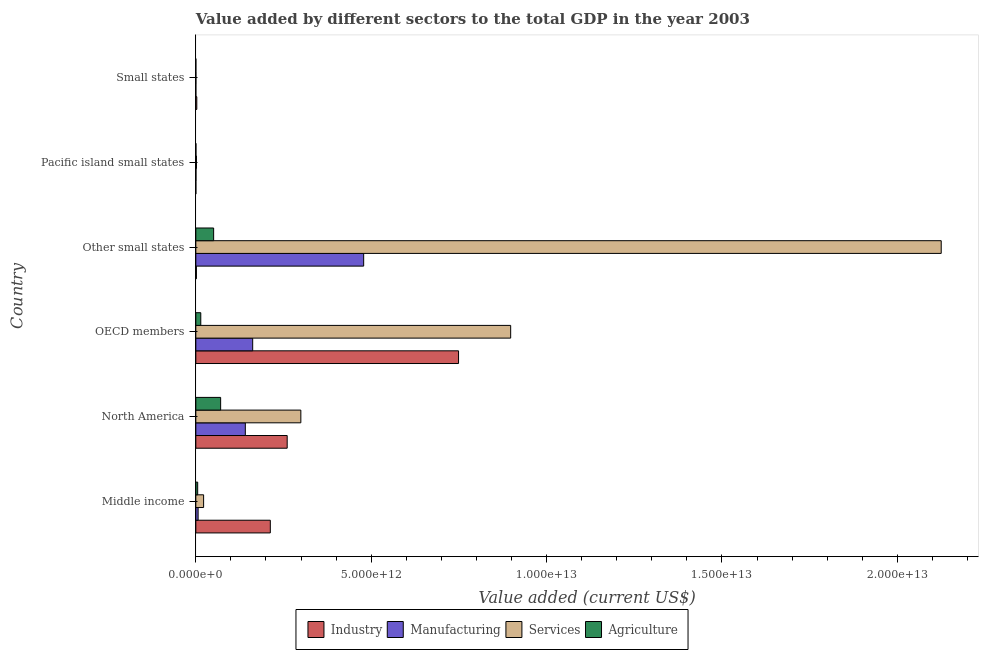How many groups of bars are there?
Provide a short and direct response. 6. Are the number of bars on each tick of the Y-axis equal?
Your answer should be very brief. Yes. How many bars are there on the 6th tick from the top?
Provide a succinct answer. 4. How many bars are there on the 1st tick from the bottom?
Provide a short and direct response. 4. What is the label of the 3rd group of bars from the top?
Keep it short and to the point. Other small states. In how many cases, is the number of bars for a given country not equal to the number of legend labels?
Offer a very short reply. 0. What is the value added by agricultural sector in Middle income?
Keep it short and to the point. 5.31e+1. Across all countries, what is the maximum value added by agricultural sector?
Offer a very short reply. 7.08e+11. Across all countries, what is the minimum value added by manufacturing sector?
Provide a succinct answer. 4.16e+08. In which country was the value added by services sector maximum?
Provide a succinct answer. Other small states. In which country was the value added by services sector minimum?
Make the answer very short. Small states. What is the total value added by manufacturing sector in the graph?
Keep it short and to the point. 7.89e+12. What is the difference between the value added by manufacturing sector in Middle income and that in Small states?
Offer a terse response. 6.48e+1. What is the difference between the value added by agricultural sector in Small states and the value added by services sector in Other small states?
Offer a very short reply. -2.13e+13. What is the average value added by industrial sector per country?
Ensure brevity in your answer.  2.04e+12. What is the difference between the value added by agricultural sector and value added by industrial sector in OECD members?
Give a very brief answer. -7.35e+12. In how many countries, is the value added by industrial sector greater than 4000000000000 US$?
Ensure brevity in your answer.  1. What is the ratio of the value added by agricultural sector in OECD members to that in Other small states?
Offer a very short reply. 0.28. Is the value added by agricultural sector in Other small states less than that in Pacific island small states?
Your answer should be compact. No. What is the difference between the highest and the second highest value added by industrial sector?
Keep it short and to the point. 4.89e+12. What is the difference between the highest and the lowest value added by manufacturing sector?
Your response must be concise. 4.78e+12. In how many countries, is the value added by agricultural sector greater than the average value added by agricultural sector taken over all countries?
Your answer should be compact. 2. What does the 2nd bar from the top in Pacific island small states represents?
Offer a terse response. Services. What does the 3rd bar from the bottom in OECD members represents?
Give a very brief answer. Services. Is it the case that in every country, the sum of the value added by industrial sector and value added by manufacturing sector is greater than the value added by services sector?
Offer a very short reply. No. Are all the bars in the graph horizontal?
Provide a succinct answer. Yes. How many countries are there in the graph?
Your answer should be compact. 6. What is the difference between two consecutive major ticks on the X-axis?
Your answer should be compact. 5.00e+12. Does the graph contain any zero values?
Offer a terse response. No. Does the graph contain grids?
Keep it short and to the point. No. Where does the legend appear in the graph?
Give a very brief answer. Bottom center. What is the title of the graph?
Keep it short and to the point. Value added by different sectors to the total GDP in the year 2003. What is the label or title of the X-axis?
Provide a short and direct response. Value added (current US$). What is the label or title of the Y-axis?
Keep it short and to the point. Country. What is the Value added (current US$) in Industry in Middle income?
Keep it short and to the point. 2.12e+12. What is the Value added (current US$) in Manufacturing in Middle income?
Your answer should be compact. 6.52e+1. What is the Value added (current US$) in Services in Middle income?
Offer a terse response. 2.22e+11. What is the Value added (current US$) in Agriculture in Middle income?
Your answer should be very brief. 5.31e+1. What is the Value added (current US$) of Industry in North America?
Your answer should be very brief. 2.60e+12. What is the Value added (current US$) in Manufacturing in North America?
Give a very brief answer. 1.41e+12. What is the Value added (current US$) in Services in North America?
Keep it short and to the point. 2.99e+12. What is the Value added (current US$) of Agriculture in North America?
Offer a terse response. 7.08e+11. What is the Value added (current US$) of Industry in OECD members?
Your answer should be very brief. 7.49e+12. What is the Value added (current US$) of Manufacturing in OECD members?
Give a very brief answer. 1.62e+12. What is the Value added (current US$) in Services in OECD members?
Make the answer very short. 8.98e+12. What is the Value added (current US$) in Agriculture in OECD members?
Offer a very short reply. 1.41e+11. What is the Value added (current US$) of Industry in Other small states?
Provide a succinct answer. 1.64e+1. What is the Value added (current US$) of Manufacturing in Other small states?
Keep it short and to the point. 4.79e+12. What is the Value added (current US$) of Services in Other small states?
Make the answer very short. 2.13e+13. What is the Value added (current US$) of Agriculture in Other small states?
Offer a terse response. 5.08e+11. What is the Value added (current US$) of Industry in Pacific island small states?
Offer a very short reply. 7.09e+08. What is the Value added (current US$) of Manufacturing in Pacific island small states?
Give a very brief answer. 4.13e+09. What is the Value added (current US$) in Services in Pacific island small states?
Offer a very short reply. 1.76e+1. What is the Value added (current US$) of Agriculture in Pacific island small states?
Ensure brevity in your answer.  2.92e+09. What is the Value added (current US$) of Industry in Small states?
Ensure brevity in your answer.  2.75e+1. What is the Value added (current US$) of Manufacturing in Small states?
Offer a terse response. 4.16e+08. What is the Value added (current US$) of Services in Small states?
Provide a short and direct response. 2.27e+09. What is the Value added (current US$) in Agriculture in Small states?
Ensure brevity in your answer.  6.69e+08. Across all countries, what is the maximum Value added (current US$) of Industry?
Give a very brief answer. 7.49e+12. Across all countries, what is the maximum Value added (current US$) of Manufacturing?
Offer a very short reply. 4.79e+12. Across all countries, what is the maximum Value added (current US$) in Services?
Your answer should be compact. 2.13e+13. Across all countries, what is the maximum Value added (current US$) in Agriculture?
Your answer should be compact. 7.08e+11. Across all countries, what is the minimum Value added (current US$) in Industry?
Keep it short and to the point. 7.09e+08. Across all countries, what is the minimum Value added (current US$) in Manufacturing?
Offer a very short reply. 4.16e+08. Across all countries, what is the minimum Value added (current US$) in Services?
Provide a short and direct response. 2.27e+09. Across all countries, what is the minimum Value added (current US$) of Agriculture?
Give a very brief answer. 6.69e+08. What is the total Value added (current US$) of Industry in the graph?
Provide a short and direct response. 1.23e+13. What is the total Value added (current US$) in Manufacturing in the graph?
Ensure brevity in your answer.  7.89e+12. What is the total Value added (current US$) in Services in the graph?
Your answer should be compact. 3.35e+13. What is the total Value added (current US$) in Agriculture in the graph?
Provide a short and direct response. 1.41e+12. What is the difference between the Value added (current US$) of Industry in Middle income and that in North America?
Give a very brief answer. -4.81e+11. What is the difference between the Value added (current US$) in Manufacturing in Middle income and that in North America?
Keep it short and to the point. -1.35e+12. What is the difference between the Value added (current US$) of Services in Middle income and that in North America?
Your answer should be very brief. -2.77e+12. What is the difference between the Value added (current US$) of Agriculture in Middle income and that in North America?
Provide a succinct answer. -6.54e+11. What is the difference between the Value added (current US$) in Industry in Middle income and that in OECD members?
Offer a very short reply. -5.37e+12. What is the difference between the Value added (current US$) in Manufacturing in Middle income and that in OECD members?
Provide a short and direct response. -1.56e+12. What is the difference between the Value added (current US$) in Services in Middle income and that in OECD members?
Keep it short and to the point. -8.75e+12. What is the difference between the Value added (current US$) in Agriculture in Middle income and that in OECD members?
Offer a very short reply. -8.81e+1. What is the difference between the Value added (current US$) of Industry in Middle income and that in Other small states?
Ensure brevity in your answer.  2.11e+12. What is the difference between the Value added (current US$) of Manufacturing in Middle income and that in Other small states?
Offer a very short reply. -4.72e+12. What is the difference between the Value added (current US$) of Services in Middle income and that in Other small states?
Keep it short and to the point. -2.10e+13. What is the difference between the Value added (current US$) in Agriculture in Middle income and that in Other small states?
Make the answer very short. -4.55e+11. What is the difference between the Value added (current US$) of Industry in Middle income and that in Pacific island small states?
Offer a very short reply. 2.12e+12. What is the difference between the Value added (current US$) of Manufacturing in Middle income and that in Pacific island small states?
Your answer should be very brief. 6.11e+1. What is the difference between the Value added (current US$) of Services in Middle income and that in Pacific island small states?
Keep it short and to the point. 2.04e+11. What is the difference between the Value added (current US$) of Agriculture in Middle income and that in Pacific island small states?
Your answer should be very brief. 5.02e+1. What is the difference between the Value added (current US$) in Industry in Middle income and that in Small states?
Your response must be concise. 2.10e+12. What is the difference between the Value added (current US$) in Manufacturing in Middle income and that in Small states?
Provide a short and direct response. 6.48e+1. What is the difference between the Value added (current US$) in Services in Middle income and that in Small states?
Offer a terse response. 2.20e+11. What is the difference between the Value added (current US$) in Agriculture in Middle income and that in Small states?
Ensure brevity in your answer.  5.24e+1. What is the difference between the Value added (current US$) in Industry in North America and that in OECD members?
Offer a terse response. -4.89e+12. What is the difference between the Value added (current US$) in Manufacturing in North America and that in OECD members?
Keep it short and to the point. -2.10e+11. What is the difference between the Value added (current US$) in Services in North America and that in OECD members?
Provide a succinct answer. -5.98e+12. What is the difference between the Value added (current US$) in Agriculture in North America and that in OECD members?
Ensure brevity in your answer.  5.66e+11. What is the difference between the Value added (current US$) in Industry in North America and that in Other small states?
Your answer should be very brief. 2.59e+12. What is the difference between the Value added (current US$) of Manufacturing in North America and that in Other small states?
Make the answer very short. -3.37e+12. What is the difference between the Value added (current US$) in Services in North America and that in Other small states?
Make the answer very short. -1.83e+13. What is the difference between the Value added (current US$) of Agriculture in North America and that in Other small states?
Give a very brief answer. 2.00e+11. What is the difference between the Value added (current US$) of Industry in North America and that in Pacific island small states?
Keep it short and to the point. 2.60e+12. What is the difference between the Value added (current US$) in Manufacturing in North America and that in Pacific island small states?
Your answer should be very brief. 1.41e+12. What is the difference between the Value added (current US$) of Services in North America and that in Pacific island small states?
Your answer should be very brief. 2.98e+12. What is the difference between the Value added (current US$) of Agriculture in North America and that in Pacific island small states?
Keep it short and to the point. 7.05e+11. What is the difference between the Value added (current US$) in Industry in North America and that in Small states?
Provide a succinct answer. 2.58e+12. What is the difference between the Value added (current US$) of Manufacturing in North America and that in Small states?
Keep it short and to the point. 1.41e+12. What is the difference between the Value added (current US$) in Services in North America and that in Small states?
Provide a short and direct response. 2.99e+12. What is the difference between the Value added (current US$) in Agriculture in North America and that in Small states?
Keep it short and to the point. 7.07e+11. What is the difference between the Value added (current US$) in Industry in OECD members and that in Other small states?
Your answer should be very brief. 7.47e+12. What is the difference between the Value added (current US$) of Manufacturing in OECD members and that in Other small states?
Give a very brief answer. -3.16e+12. What is the difference between the Value added (current US$) in Services in OECD members and that in Other small states?
Give a very brief answer. -1.23e+13. What is the difference between the Value added (current US$) of Agriculture in OECD members and that in Other small states?
Offer a terse response. -3.67e+11. What is the difference between the Value added (current US$) in Industry in OECD members and that in Pacific island small states?
Provide a succinct answer. 7.49e+12. What is the difference between the Value added (current US$) in Manufacturing in OECD members and that in Pacific island small states?
Keep it short and to the point. 1.62e+12. What is the difference between the Value added (current US$) in Services in OECD members and that in Pacific island small states?
Provide a short and direct response. 8.96e+12. What is the difference between the Value added (current US$) of Agriculture in OECD members and that in Pacific island small states?
Your response must be concise. 1.38e+11. What is the difference between the Value added (current US$) in Industry in OECD members and that in Small states?
Offer a very short reply. 7.46e+12. What is the difference between the Value added (current US$) in Manufacturing in OECD members and that in Small states?
Give a very brief answer. 1.62e+12. What is the difference between the Value added (current US$) of Services in OECD members and that in Small states?
Ensure brevity in your answer.  8.97e+12. What is the difference between the Value added (current US$) in Agriculture in OECD members and that in Small states?
Offer a very short reply. 1.41e+11. What is the difference between the Value added (current US$) of Industry in Other small states and that in Pacific island small states?
Provide a short and direct response. 1.57e+1. What is the difference between the Value added (current US$) of Manufacturing in Other small states and that in Pacific island small states?
Your answer should be compact. 4.78e+12. What is the difference between the Value added (current US$) of Services in Other small states and that in Pacific island small states?
Keep it short and to the point. 2.12e+13. What is the difference between the Value added (current US$) in Agriculture in Other small states and that in Pacific island small states?
Offer a terse response. 5.05e+11. What is the difference between the Value added (current US$) of Industry in Other small states and that in Small states?
Make the answer very short. -1.11e+1. What is the difference between the Value added (current US$) in Manufacturing in Other small states and that in Small states?
Your answer should be compact. 4.78e+12. What is the difference between the Value added (current US$) in Services in Other small states and that in Small states?
Your answer should be compact. 2.12e+13. What is the difference between the Value added (current US$) in Agriculture in Other small states and that in Small states?
Your response must be concise. 5.07e+11. What is the difference between the Value added (current US$) of Industry in Pacific island small states and that in Small states?
Ensure brevity in your answer.  -2.68e+1. What is the difference between the Value added (current US$) in Manufacturing in Pacific island small states and that in Small states?
Your answer should be very brief. 3.71e+09. What is the difference between the Value added (current US$) of Services in Pacific island small states and that in Small states?
Offer a terse response. 1.54e+1. What is the difference between the Value added (current US$) in Agriculture in Pacific island small states and that in Small states?
Your response must be concise. 2.25e+09. What is the difference between the Value added (current US$) in Industry in Middle income and the Value added (current US$) in Manufacturing in North America?
Your answer should be very brief. 7.12e+11. What is the difference between the Value added (current US$) of Industry in Middle income and the Value added (current US$) of Services in North America?
Your answer should be compact. -8.70e+11. What is the difference between the Value added (current US$) in Industry in Middle income and the Value added (current US$) in Agriculture in North America?
Your answer should be compact. 1.42e+12. What is the difference between the Value added (current US$) in Manufacturing in Middle income and the Value added (current US$) in Services in North America?
Ensure brevity in your answer.  -2.93e+12. What is the difference between the Value added (current US$) in Manufacturing in Middle income and the Value added (current US$) in Agriculture in North America?
Provide a short and direct response. -6.42e+11. What is the difference between the Value added (current US$) in Services in Middle income and the Value added (current US$) in Agriculture in North America?
Ensure brevity in your answer.  -4.86e+11. What is the difference between the Value added (current US$) in Industry in Middle income and the Value added (current US$) in Manufacturing in OECD members?
Make the answer very short. 5.03e+11. What is the difference between the Value added (current US$) in Industry in Middle income and the Value added (current US$) in Services in OECD members?
Your response must be concise. -6.85e+12. What is the difference between the Value added (current US$) in Industry in Middle income and the Value added (current US$) in Agriculture in OECD members?
Offer a very short reply. 1.98e+12. What is the difference between the Value added (current US$) in Manufacturing in Middle income and the Value added (current US$) in Services in OECD members?
Keep it short and to the point. -8.91e+12. What is the difference between the Value added (current US$) of Manufacturing in Middle income and the Value added (current US$) of Agriculture in OECD members?
Offer a terse response. -7.60e+1. What is the difference between the Value added (current US$) of Services in Middle income and the Value added (current US$) of Agriculture in OECD members?
Ensure brevity in your answer.  8.07e+1. What is the difference between the Value added (current US$) of Industry in Middle income and the Value added (current US$) of Manufacturing in Other small states?
Your response must be concise. -2.66e+12. What is the difference between the Value added (current US$) of Industry in Middle income and the Value added (current US$) of Services in Other small states?
Your answer should be very brief. -1.91e+13. What is the difference between the Value added (current US$) of Industry in Middle income and the Value added (current US$) of Agriculture in Other small states?
Make the answer very short. 1.62e+12. What is the difference between the Value added (current US$) in Manufacturing in Middle income and the Value added (current US$) in Services in Other small states?
Your answer should be very brief. -2.12e+13. What is the difference between the Value added (current US$) of Manufacturing in Middle income and the Value added (current US$) of Agriculture in Other small states?
Your answer should be compact. -4.43e+11. What is the difference between the Value added (current US$) of Services in Middle income and the Value added (current US$) of Agriculture in Other small states?
Offer a very short reply. -2.86e+11. What is the difference between the Value added (current US$) of Industry in Middle income and the Value added (current US$) of Manufacturing in Pacific island small states?
Ensure brevity in your answer.  2.12e+12. What is the difference between the Value added (current US$) in Industry in Middle income and the Value added (current US$) in Services in Pacific island small states?
Offer a terse response. 2.11e+12. What is the difference between the Value added (current US$) in Industry in Middle income and the Value added (current US$) in Agriculture in Pacific island small states?
Offer a terse response. 2.12e+12. What is the difference between the Value added (current US$) in Manufacturing in Middle income and the Value added (current US$) in Services in Pacific island small states?
Your answer should be compact. 4.76e+1. What is the difference between the Value added (current US$) of Manufacturing in Middle income and the Value added (current US$) of Agriculture in Pacific island small states?
Keep it short and to the point. 6.23e+1. What is the difference between the Value added (current US$) of Services in Middle income and the Value added (current US$) of Agriculture in Pacific island small states?
Provide a succinct answer. 2.19e+11. What is the difference between the Value added (current US$) in Industry in Middle income and the Value added (current US$) in Manufacturing in Small states?
Your answer should be compact. 2.12e+12. What is the difference between the Value added (current US$) in Industry in Middle income and the Value added (current US$) in Services in Small states?
Your answer should be compact. 2.12e+12. What is the difference between the Value added (current US$) in Industry in Middle income and the Value added (current US$) in Agriculture in Small states?
Ensure brevity in your answer.  2.12e+12. What is the difference between the Value added (current US$) in Manufacturing in Middle income and the Value added (current US$) in Services in Small states?
Your answer should be very brief. 6.29e+1. What is the difference between the Value added (current US$) of Manufacturing in Middle income and the Value added (current US$) of Agriculture in Small states?
Provide a succinct answer. 6.45e+1. What is the difference between the Value added (current US$) of Services in Middle income and the Value added (current US$) of Agriculture in Small states?
Your answer should be very brief. 2.21e+11. What is the difference between the Value added (current US$) in Industry in North America and the Value added (current US$) in Manufacturing in OECD members?
Your response must be concise. 9.84e+11. What is the difference between the Value added (current US$) of Industry in North America and the Value added (current US$) of Services in OECD members?
Make the answer very short. -6.37e+12. What is the difference between the Value added (current US$) of Industry in North America and the Value added (current US$) of Agriculture in OECD members?
Keep it short and to the point. 2.46e+12. What is the difference between the Value added (current US$) of Manufacturing in North America and the Value added (current US$) of Services in OECD members?
Your answer should be very brief. -7.57e+12. What is the difference between the Value added (current US$) in Manufacturing in North America and the Value added (current US$) in Agriculture in OECD members?
Offer a very short reply. 1.27e+12. What is the difference between the Value added (current US$) in Services in North America and the Value added (current US$) in Agriculture in OECD members?
Give a very brief answer. 2.85e+12. What is the difference between the Value added (current US$) in Industry in North America and the Value added (current US$) in Manufacturing in Other small states?
Keep it short and to the point. -2.18e+12. What is the difference between the Value added (current US$) of Industry in North America and the Value added (current US$) of Services in Other small states?
Your response must be concise. -1.86e+13. What is the difference between the Value added (current US$) in Industry in North America and the Value added (current US$) in Agriculture in Other small states?
Your answer should be very brief. 2.10e+12. What is the difference between the Value added (current US$) in Manufacturing in North America and the Value added (current US$) in Services in Other small states?
Make the answer very short. -1.98e+13. What is the difference between the Value added (current US$) in Manufacturing in North America and the Value added (current US$) in Agriculture in Other small states?
Your answer should be compact. 9.03e+11. What is the difference between the Value added (current US$) of Services in North America and the Value added (current US$) of Agriculture in Other small states?
Your response must be concise. 2.49e+12. What is the difference between the Value added (current US$) in Industry in North America and the Value added (current US$) in Manufacturing in Pacific island small states?
Offer a terse response. 2.60e+12. What is the difference between the Value added (current US$) of Industry in North America and the Value added (current US$) of Services in Pacific island small states?
Give a very brief answer. 2.59e+12. What is the difference between the Value added (current US$) of Industry in North America and the Value added (current US$) of Agriculture in Pacific island small states?
Make the answer very short. 2.60e+12. What is the difference between the Value added (current US$) of Manufacturing in North America and the Value added (current US$) of Services in Pacific island small states?
Provide a short and direct response. 1.39e+12. What is the difference between the Value added (current US$) of Manufacturing in North America and the Value added (current US$) of Agriculture in Pacific island small states?
Your answer should be compact. 1.41e+12. What is the difference between the Value added (current US$) of Services in North America and the Value added (current US$) of Agriculture in Pacific island small states?
Your answer should be very brief. 2.99e+12. What is the difference between the Value added (current US$) in Industry in North America and the Value added (current US$) in Manufacturing in Small states?
Make the answer very short. 2.60e+12. What is the difference between the Value added (current US$) in Industry in North America and the Value added (current US$) in Services in Small states?
Give a very brief answer. 2.60e+12. What is the difference between the Value added (current US$) in Industry in North America and the Value added (current US$) in Agriculture in Small states?
Offer a very short reply. 2.60e+12. What is the difference between the Value added (current US$) of Manufacturing in North America and the Value added (current US$) of Services in Small states?
Provide a short and direct response. 1.41e+12. What is the difference between the Value added (current US$) of Manufacturing in North America and the Value added (current US$) of Agriculture in Small states?
Your answer should be compact. 1.41e+12. What is the difference between the Value added (current US$) in Services in North America and the Value added (current US$) in Agriculture in Small states?
Your response must be concise. 2.99e+12. What is the difference between the Value added (current US$) in Industry in OECD members and the Value added (current US$) in Manufacturing in Other small states?
Ensure brevity in your answer.  2.71e+12. What is the difference between the Value added (current US$) of Industry in OECD members and the Value added (current US$) of Services in Other small states?
Provide a succinct answer. -1.38e+13. What is the difference between the Value added (current US$) in Industry in OECD members and the Value added (current US$) in Agriculture in Other small states?
Provide a short and direct response. 6.98e+12. What is the difference between the Value added (current US$) of Manufacturing in OECD members and the Value added (current US$) of Services in Other small states?
Your answer should be compact. -1.96e+13. What is the difference between the Value added (current US$) of Manufacturing in OECD members and the Value added (current US$) of Agriculture in Other small states?
Ensure brevity in your answer.  1.11e+12. What is the difference between the Value added (current US$) of Services in OECD members and the Value added (current US$) of Agriculture in Other small states?
Give a very brief answer. 8.47e+12. What is the difference between the Value added (current US$) of Industry in OECD members and the Value added (current US$) of Manufacturing in Pacific island small states?
Ensure brevity in your answer.  7.49e+12. What is the difference between the Value added (current US$) of Industry in OECD members and the Value added (current US$) of Services in Pacific island small states?
Provide a succinct answer. 7.47e+12. What is the difference between the Value added (current US$) in Industry in OECD members and the Value added (current US$) in Agriculture in Pacific island small states?
Make the answer very short. 7.49e+12. What is the difference between the Value added (current US$) of Manufacturing in OECD members and the Value added (current US$) of Services in Pacific island small states?
Give a very brief answer. 1.60e+12. What is the difference between the Value added (current US$) of Manufacturing in OECD members and the Value added (current US$) of Agriculture in Pacific island small states?
Offer a terse response. 1.62e+12. What is the difference between the Value added (current US$) in Services in OECD members and the Value added (current US$) in Agriculture in Pacific island small states?
Your answer should be compact. 8.97e+12. What is the difference between the Value added (current US$) of Industry in OECD members and the Value added (current US$) of Manufacturing in Small states?
Offer a terse response. 7.49e+12. What is the difference between the Value added (current US$) in Industry in OECD members and the Value added (current US$) in Services in Small states?
Give a very brief answer. 7.49e+12. What is the difference between the Value added (current US$) of Industry in OECD members and the Value added (current US$) of Agriculture in Small states?
Your answer should be compact. 7.49e+12. What is the difference between the Value added (current US$) of Manufacturing in OECD members and the Value added (current US$) of Services in Small states?
Your answer should be compact. 1.62e+12. What is the difference between the Value added (current US$) of Manufacturing in OECD members and the Value added (current US$) of Agriculture in Small states?
Your answer should be compact. 1.62e+12. What is the difference between the Value added (current US$) in Services in OECD members and the Value added (current US$) in Agriculture in Small states?
Provide a short and direct response. 8.98e+12. What is the difference between the Value added (current US$) of Industry in Other small states and the Value added (current US$) of Manufacturing in Pacific island small states?
Your answer should be very brief. 1.23e+1. What is the difference between the Value added (current US$) of Industry in Other small states and the Value added (current US$) of Services in Pacific island small states?
Offer a terse response. -1.22e+09. What is the difference between the Value added (current US$) of Industry in Other small states and the Value added (current US$) of Agriculture in Pacific island small states?
Make the answer very short. 1.35e+1. What is the difference between the Value added (current US$) of Manufacturing in Other small states and the Value added (current US$) of Services in Pacific island small states?
Provide a short and direct response. 4.77e+12. What is the difference between the Value added (current US$) of Manufacturing in Other small states and the Value added (current US$) of Agriculture in Pacific island small states?
Make the answer very short. 4.78e+12. What is the difference between the Value added (current US$) in Services in Other small states and the Value added (current US$) in Agriculture in Pacific island small states?
Provide a short and direct response. 2.12e+13. What is the difference between the Value added (current US$) of Industry in Other small states and the Value added (current US$) of Manufacturing in Small states?
Provide a short and direct response. 1.60e+1. What is the difference between the Value added (current US$) of Industry in Other small states and the Value added (current US$) of Services in Small states?
Your response must be concise. 1.41e+1. What is the difference between the Value added (current US$) in Industry in Other small states and the Value added (current US$) in Agriculture in Small states?
Provide a short and direct response. 1.57e+1. What is the difference between the Value added (current US$) of Manufacturing in Other small states and the Value added (current US$) of Services in Small states?
Keep it short and to the point. 4.78e+12. What is the difference between the Value added (current US$) of Manufacturing in Other small states and the Value added (current US$) of Agriculture in Small states?
Your answer should be compact. 4.78e+12. What is the difference between the Value added (current US$) in Services in Other small states and the Value added (current US$) in Agriculture in Small states?
Give a very brief answer. 2.13e+13. What is the difference between the Value added (current US$) in Industry in Pacific island small states and the Value added (current US$) in Manufacturing in Small states?
Offer a very short reply. 2.93e+08. What is the difference between the Value added (current US$) in Industry in Pacific island small states and the Value added (current US$) in Services in Small states?
Your response must be concise. -1.56e+09. What is the difference between the Value added (current US$) in Industry in Pacific island small states and the Value added (current US$) in Agriculture in Small states?
Offer a very short reply. 4.02e+07. What is the difference between the Value added (current US$) in Manufacturing in Pacific island small states and the Value added (current US$) in Services in Small states?
Ensure brevity in your answer.  1.86e+09. What is the difference between the Value added (current US$) in Manufacturing in Pacific island small states and the Value added (current US$) in Agriculture in Small states?
Your answer should be very brief. 3.46e+09. What is the difference between the Value added (current US$) of Services in Pacific island small states and the Value added (current US$) of Agriculture in Small states?
Your answer should be very brief. 1.70e+1. What is the average Value added (current US$) of Industry per country?
Provide a succinct answer. 2.04e+12. What is the average Value added (current US$) of Manufacturing per country?
Your response must be concise. 1.31e+12. What is the average Value added (current US$) in Services per country?
Your answer should be compact. 5.58e+12. What is the average Value added (current US$) of Agriculture per country?
Offer a very short reply. 2.36e+11. What is the difference between the Value added (current US$) in Industry and Value added (current US$) in Manufacturing in Middle income?
Your response must be concise. 2.06e+12. What is the difference between the Value added (current US$) of Industry and Value added (current US$) of Services in Middle income?
Provide a succinct answer. 1.90e+12. What is the difference between the Value added (current US$) in Industry and Value added (current US$) in Agriculture in Middle income?
Provide a succinct answer. 2.07e+12. What is the difference between the Value added (current US$) of Manufacturing and Value added (current US$) of Services in Middle income?
Your answer should be very brief. -1.57e+11. What is the difference between the Value added (current US$) in Manufacturing and Value added (current US$) in Agriculture in Middle income?
Provide a succinct answer. 1.21e+1. What is the difference between the Value added (current US$) in Services and Value added (current US$) in Agriculture in Middle income?
Your response must be concise. 1.69e+11. What is the difference between the Value added (current US$) of Industry and Value added (current US$) of Manufacturing in North America?
Keep it short and to the point. 1.19e+12. What is the difference between the Value added (current US$) of Industry and Value added (current US$) of Services in North America?
Make the answer very short. -3.89e+11. What is the difference between the Value added (current US$) in Industry and Value added (current US$) in Agriculture in North America?
Provide a short and direct response. 1.90e+12. What is the difference between the Value added (current US$) in Manufacturing and Value added (current US$) in Services in North America?
Your answer should be compact. -1.58e+12. What is the difference between the Value added (current US$) of Manufacturing and Value added (current US$) of Agriculture in North America?
Offer a terse response. 7.04e+11. What is the difference between the Value added (current US$) in Services and Value added (current US$) in Agriculture in North America?
Ensure brevity in your answer.  2.29e+12. What is the difference between the Value added (current US$) of Industry and Value added (current US$) of Manufacturing in OECD members?
Your answer should be compact. 5.87e+12. What is the difference between the Value added (current US$) in Industry and Value added (current US$) in Services in OECD members?
Your answer should be very brief. -1.49e+12. What is the difference between the Value added (current US$) of Industry and Value added (current US$) of Agriculture in OECD members?
Provide a short and direct response. 7.35e+12. What is the difference between the Value added (current US$) in Manufacturing and Value added (current US$) in Services in OECD members?
Offer a very short reply. -7.36e+12. What is the difference between the Value added (current US$) of Manufacturing and Value added (current US$) of Agriculture in OECD members?
Offer a very short reply. 1.48e+12. What is the difference between the Value added (current US$) in Services and Value added (current US$) in Agriculture in OECD members?
Give a very brief answer. 8.84e+12. What is the difference between the Value added (current US$) in Industry and Value added (current US$) in Manufacturing in Other small states?
Your answer should be compact. -4.77e+12. What is the difference between the Value added (current US$) in Industry and Value added (current US$) in Services in Other small states?
Offer a very short reply. -2.12e+13. What is the difference between the Value added (current US$) of Industry and Value added (current US$) of Agriculture in Other small states?
Ensure brevity in your answer.  -4.91e+11. What is the difference between the Value added (current US$) in Manufacturing and Value added (current US$) in Services in Other small states?
Make the answer very short. -1.65e+13. What is the difference between the Value added (current US$) of Manufacturing and Value added (current US$) of Agriculture in Other small states?
Provide a short and direct response. 4.28e+12. What is the difference between the Value added (current US$) of Services and Value added (current US$) of Agriculture in Other small states?
Provide a short and direct response. 2.07e+13. What is the difference between the Value added (current US$) in Industry and Value added (current US$) in Manufacturing in Pacific island small states?
Keep it short and to the point. -3.42e+09. What is the difference between the Value added (current US$) of Industry and Value added (current US$) of Services in Pacific island small states?
Provide a succinct answer. -1.69e+1. What is the difference between the Value added (current US$) of Industry and Value added (current US$) of Agriculture in Pacific island small states?
Provide a succinct answer. -2.21e+09. What is the difference between the Value added (current US$) of Manufacturing and Value added (current US$) of Services in Pacific island small states?
Offer a terse response. -1.35e+1. What is the difference between the Value added (current US$) in Manufacturing and Value added (current US$) in Agriculture in Pacific island small states?
Give a very brief answer. 1.21e+09. What is the difference between the Value added (current US$) in Services and Value added (current US$) in Agriculture in Pacific island small states?
Your answer should be very brief. 1.47e+1. What is the difference between the Value added (current US$) in Industry and Value added (current US$) in Manufacturing in Small states?
Ensure brevity in your answer.  2.71e+1. What is the difference between the Value added (current US$) in Industry and Value added (current US$) in Services in Small states?
Provide a short and direct response. 2.52e+1. What is the difference between the Value added (current US$) of Industry and Value added (current US$) of Agriculture in Small states?
Make the answer very short. 2.68e+1. What is the difference between the Value added (current US$) in Manufacturing and Value added (current US$) in Services in Small states?
Your response must be concise. -1.85e+09. What is the difference between the Value added (current US$) in Manufacturing and Value added (current US$) in Agriculture in Small states?
Provide a succinct answer. -2.53e+08. What is the difference between the Value added (current US$) of Services and Value added (current US$) of Agriculture in Small states?
Give a very brief answer. 1.60e+09. What is the ratio of the Value added (current US$) of Industry in Middle income to that in North America?
Your response must be concise. 0.82. What is the ratio of the Value added (current US$) in Manufacturing in Middle income to that in North America?
Offer a terse response. 0.05. What is the ratio of the Value added (current US$) of Services in Middle income to that in North America?
Make the answer very short. 0.07. What is the ratio of the Value added (current US$) in Agriculture in Middle income to that in North America?
Keep it short and to the point. 0.07. What is the ratio of the Value added (current US$) of Industry in Middle income to that in OECD members?
Make the answer very short. 0.28. What is the ratio of the Value added (current US$) in Manufacturing in Middle income to that in OECD members?
Your response must be concise. 0.04. What is the ratio of the Value added (current US$) in Services in Middle income to that in OECD members?
Your response must be concise. 0.02. What is the ratio of the Value added (current US$) of Agriculture in Middle income to that in OECD members?
Offer a very short reply. 0.38. What is the ratio of the Value added (current US$) in Industry in Middle income to that in Other small states?
Ensure brevity in your answer.  129.37. What is the ratio of the Value added (current US$) in Manufacturing in Middle income to that in Other small states?
Offer a very short reply. 0.01. What is the ratio of the Value added (current US$) of Services in Middle income to that in Other small states?
Keep it short and to the point. 0.01. What is the ratio of the Value added (current US$) of Agriculture in Middle income to that in Other small states?
Your response must be concise. 0.1. What is the ratio of the Value added (current US$) of Industry in Middle income to that in Pacific island small states?
Your answer should be very brief. 2995.25. What is the ratio of the Value added (current US$) in Manufacturing in Middle income to that in Pacific island small states?
Your answer should be compact. 15.8. What is the ratio of the Value added (current US$) of Services in Middle income to that in Pacific island small states?
Offer a very short reply. 12.58. What is the ratio of the Value added (current US$) in Agriculture in Middle income to that in Pacific island small states?
Your response must be concise. 18.21. What is the ratio of the Value added (current US$) in Industry in Middle income to that in Small states?
Make the answer very short. 77.25. What is the ratio of the Value added (current US$) of Manufacturing in Middle income to that in Small states?
Make the answer very short. 156.9. What is the ratio of the Value added (current US$) of Services in Middle income to that in Small states?
Your answer should be compact. 97.83. What is the ratio of the Value added (current US$) in Agriculture in Middle income to that in Small states?
Give a very brief answer. 79.38. What is the ratio of the Value added (current US$) of Industry in North America to that in OECD members?
Provide a succinct answer. 0.35. What is the ratio of the Value added (current US$) of Manufacturing in North America to that in OECD members?
Your answer should be very brief. 0.87. What is the ratio of the Value added (current US$) in Services in North America to that in OECD members?
Your answer should be very brief. 0.33. What is the ratio of the Value added (current US$) in Agriculture in North America to that in OECD members?
Your answer should be compact. 5.01. What is the ratio of the Value added (current US$) in Industry in North America to that in Other small states?
Your answer should be compact. 158.68. What is the ratio of the Value added (current US$) in Manufacturing in North America to that in Other small states?
Offer a terse response. 0.29. What is the ratio of the Value added (current US$) in Services in North America to that in Other small states?
Offer a terse response. 0.14. What is the ratio of the Value added (current US$) of Agriculture in North America to that in Other small states?
Give a very brief answer. 1.39. What is the ratio of the Value added (current US$) in Industry in North America to that in Pacific island small states?
Provide a short and direct response. 3673.73. What is the ratio of the Value added (current US$) in Manufacturing in North America to that in Pacific island small states?
Your response must be concise. 341.91. What is the ratio of the Value added (current US$) in Services in North America to that in Pacific island small states?
Keep it short and to the point. 169.82. What is the ratio of the Value added (current US$) of Agriculture in North America to that in Pacific island small states?
Provide a short and direct response. 242.7. What is the ratio of the Value added (current US$) of Industry in North America to that in Small states?
Your answer should be compact. 94.74. What is the ratio of the Value added (current US$) of Manufacturing in North America to that in Small states?
Your answer should be very brief. 3395.31. What is the ratio of the Value added (current US$) in Services in North America to that in Small states?
Your answer should be compact. 1320.27. What is the ratio of the Value added (current US$) in Agriculture in North America to that in Small states?
Make the answer very short. 1057.99. What is the ratio of the Value added (current US$) in Industry in OECD members to that in Other small states?
Ensure brevity in your answer.  456.33. What is the ratio of the Value added (current US$) of Manufacturing in OECD members to that in Other small states?
Your answer should be very brief. 0.34. What is the ratio of the Value added (current US$) of Services in OECD members to that in Other small states?
Your answer should be very brief. 0.42. What is the ratio of the Value added (current US$) of Agriculture in OECD members to that in Other small states?
Offer a terse response. 0.28. What is the ratio of the Value added (current US$) of Industry in OECD members to that in Pacific island small states?
Your answer should be compact. 1.06e+04. What is the ratio of the Value added (current US$) of Manufacturing in OECD members to that in Pacific island small states?
Make the answer very short. 392.76. What is the ratio of the Value added (current US$) in Services in OECD members to that in Pacific island small states?
Keep it short and to the point. 509.15. What is the ratio of the Value added (current US$) of Agriculture in OECD members to that in Pacific island small states?
Provide a succinct answer. 48.43. What is the ratio of the Value added (current US$) of Industry in OECD members to that in Small states?
Keep it short and to the point. 272.47. What is the ratio of the Value added (current US$) of Manufacturing in OECD members to that in Small states?
Offer a terse response. 3900.22. What is the ratio of the Value added (current US$) in Services in OECD members to that in Small states?
Offer a very short reply. 3958.32. What is the ratio of the Value added (current US$) of Agriculture in OECD members to that in Small states?
Provide a short and direct response. 211.13. What is the ratio of the Value added (current US$) in Industry in Other small states to that in Pacific island small states?
Your answer should be very brief. 23.15. What is the ratio of the Value added (current US$) of Manufacturing in Other small states to that in Pacific island small states?
Provide a short and direct response. 1159.46. What is the ratio of the Value added (current US$) of Services in Other small states to that in Pacific island small states?
Offer a very short reply. 1205.39. What is the ratio of the Value added (current US$) in Agriculture in Other small states to that in Pacific island small states?
Your answer should be compact. 174.19. What is the ratio of the Value added (current US$) of Industry in Other small states to that in Small states?
Provide a short and direct response. 0.6. What is the ratio of the Value added (current US$) of Manufacturing in Other small states to that in Small states?
Offer a very short reply. 1.15e+04. What is the ratio of the Value added (current US$) of Services in Other small states to that in Small states?
Your answer should be compact. 9371.11. What is the ratio of the Value added (current US$) of Agriculture in Other small states to that in Small states?
Your answer should be compact. 759.34. What is the ratio of the Value added (current US$) of Industry in Pacific island small states to that in Small states?
Provide a short and direct response. 0.03. What is the ratio of the Value added (current US$) of Manufacturing in Pacific island small states to that in Small states?
Offer a terse response. 9.93. What is the ratio of the Value added (current US$) of Services in Pacific island small states to that in Small states?
Make the answer very short. 7.77. What is the ratio of the Value added (current US$) of Agriculture in Pacific island small states to that in Small states?
Your answer should be very brief. 4.36. What is the difference between the highest and the second highest Value added (current US$) in Industry?
Provide a succinct answer. 4.89e+12. What is the difference between the highest and the second highest Value added (current US$) of Manufacturing?
Your answer should be very brief. 3.16e+12. What is the difference between the highest and the second highest Value added (current US$) in Services?
Offer a terse response. 1.23e+13. What is the difference between the highest and the second highest Value added (current US$) of Agriculture?
Your response must be concise. 2.00e+11. What is the difference between the highest and the lowest Value added (current US$) of Industry?
Ensure brevity in your answer.  7.49e+12. What is the difference between the highest and the lowest Value added (current US$) of Manufacturing?
Offer a very short reply. 4.78e+12. What is the difference between the highest and the lowest Value added (current US$) of Services?
Ensure brevity in your answer.  2.12e+13. What is the difference between the highest and the lowest Value added (current US$) of Agriculture?
Provide a short and direct response. 7.07e+11. 